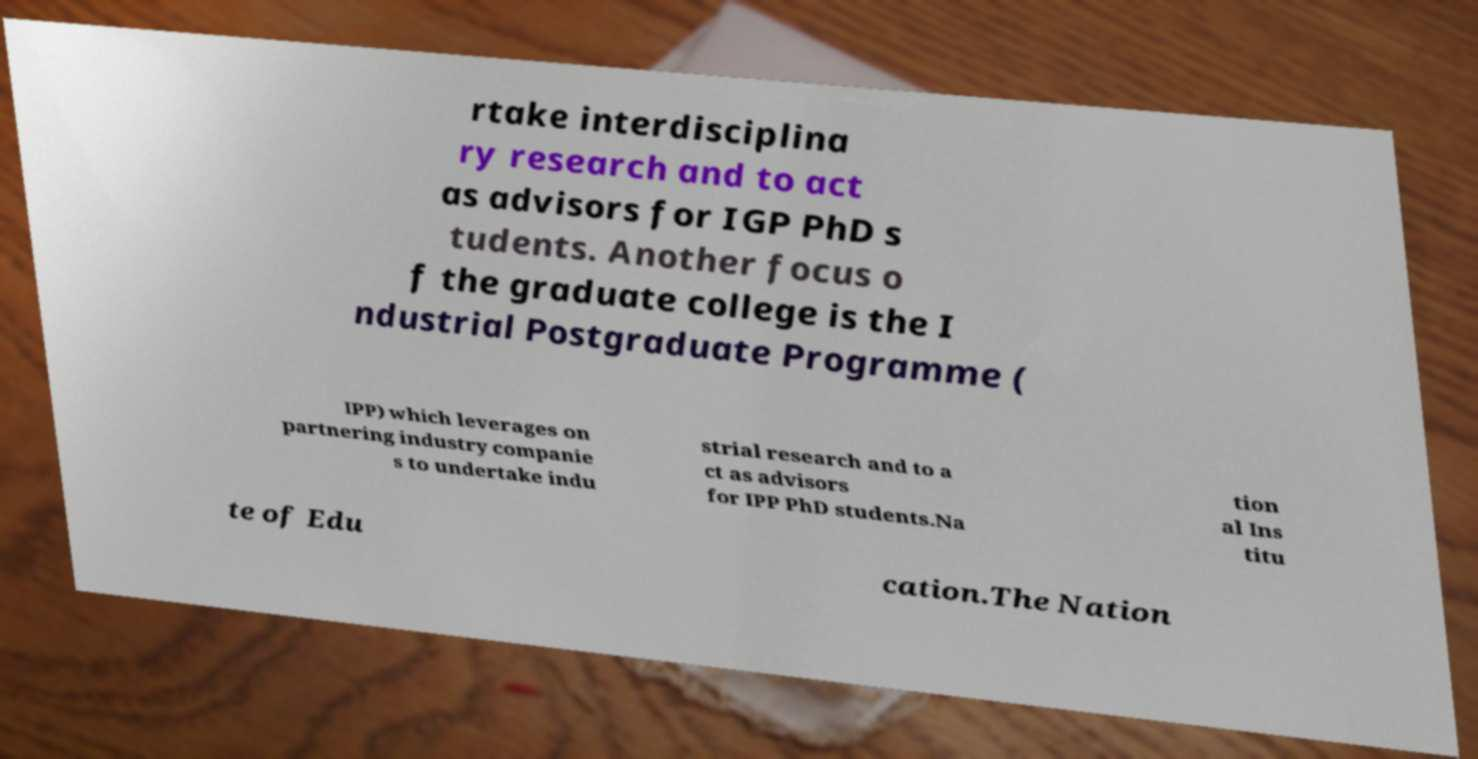Can you read and provide the text displayed in the image?This photo seems to have some interesting text. Can you extract and type it out for me? rtake interdisciplina ry research and to act as advisors for IGP PhD s tudents. Another focus o f the graduate college is the I ndustrial Postgraduate Programme ( IPP) which leverages on partnering industry companie s to undertake indu strial research and to a ct as advisors for IPP PhD students.Na tion al Ins titu te of Edu cation.The Nation 